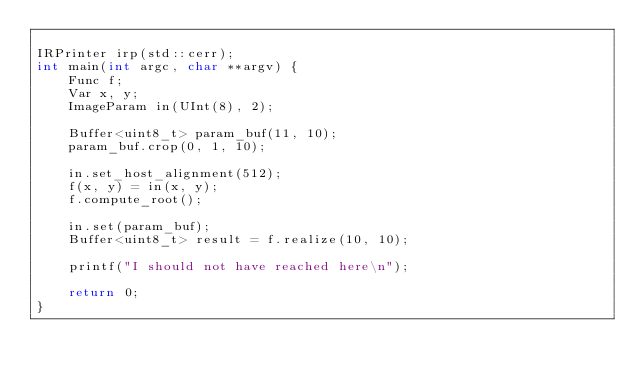Convert code to text. <code><loc_0><loc_0><loc_500><loc_500><_C++_>
IRPrinter irp(std::cerr);
int main(int argc, char **argv) {
    Func f;
    Var x, y;
    ImageParam in(UInt(8), 2);

    Buffer<uint8_t> param_buf(11, 10);
    param_buf.crop(0, 1, 10);

    in.set_host_alignment(512);
    f(x, y) = in(x, y);
    f.compute_root();

    in.set(param_buf);
    Buffer<uint8_t> result = f.realize(10, 10);

    printf("I should not have reached here\n");

    return 0;
}
</code> 